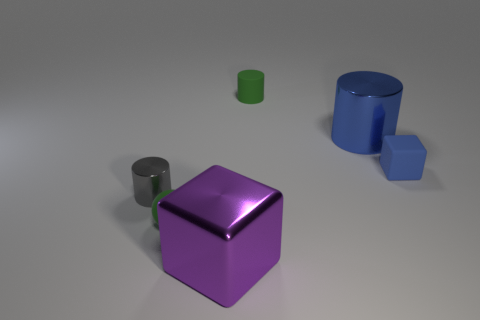Add 1 big brown shiny balls. How many objects exist? 7 Subtract all blocks. How many objects are left? 4 Subtract 1 purple blocks. How many objects are left? 5 Subtract all tiny cyan cubes. Subtract all tiny cubes. How many objects are left? 5 Add 1 tiny things. How many tiny things are left? 5 Add 4 tiny yellow metallic spheres. How many tiny yellow metallic spheres exist? 4 